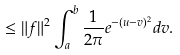<formula> <loc_0><loc_0><loc_500><loc_500>\leq \| f \| ^ { 2 } \int ^ { b } _ { a } \frac { 1 } { 2 \pi } e ^ { - ( u - v ) ^ { 2 } } d v .</formula> 